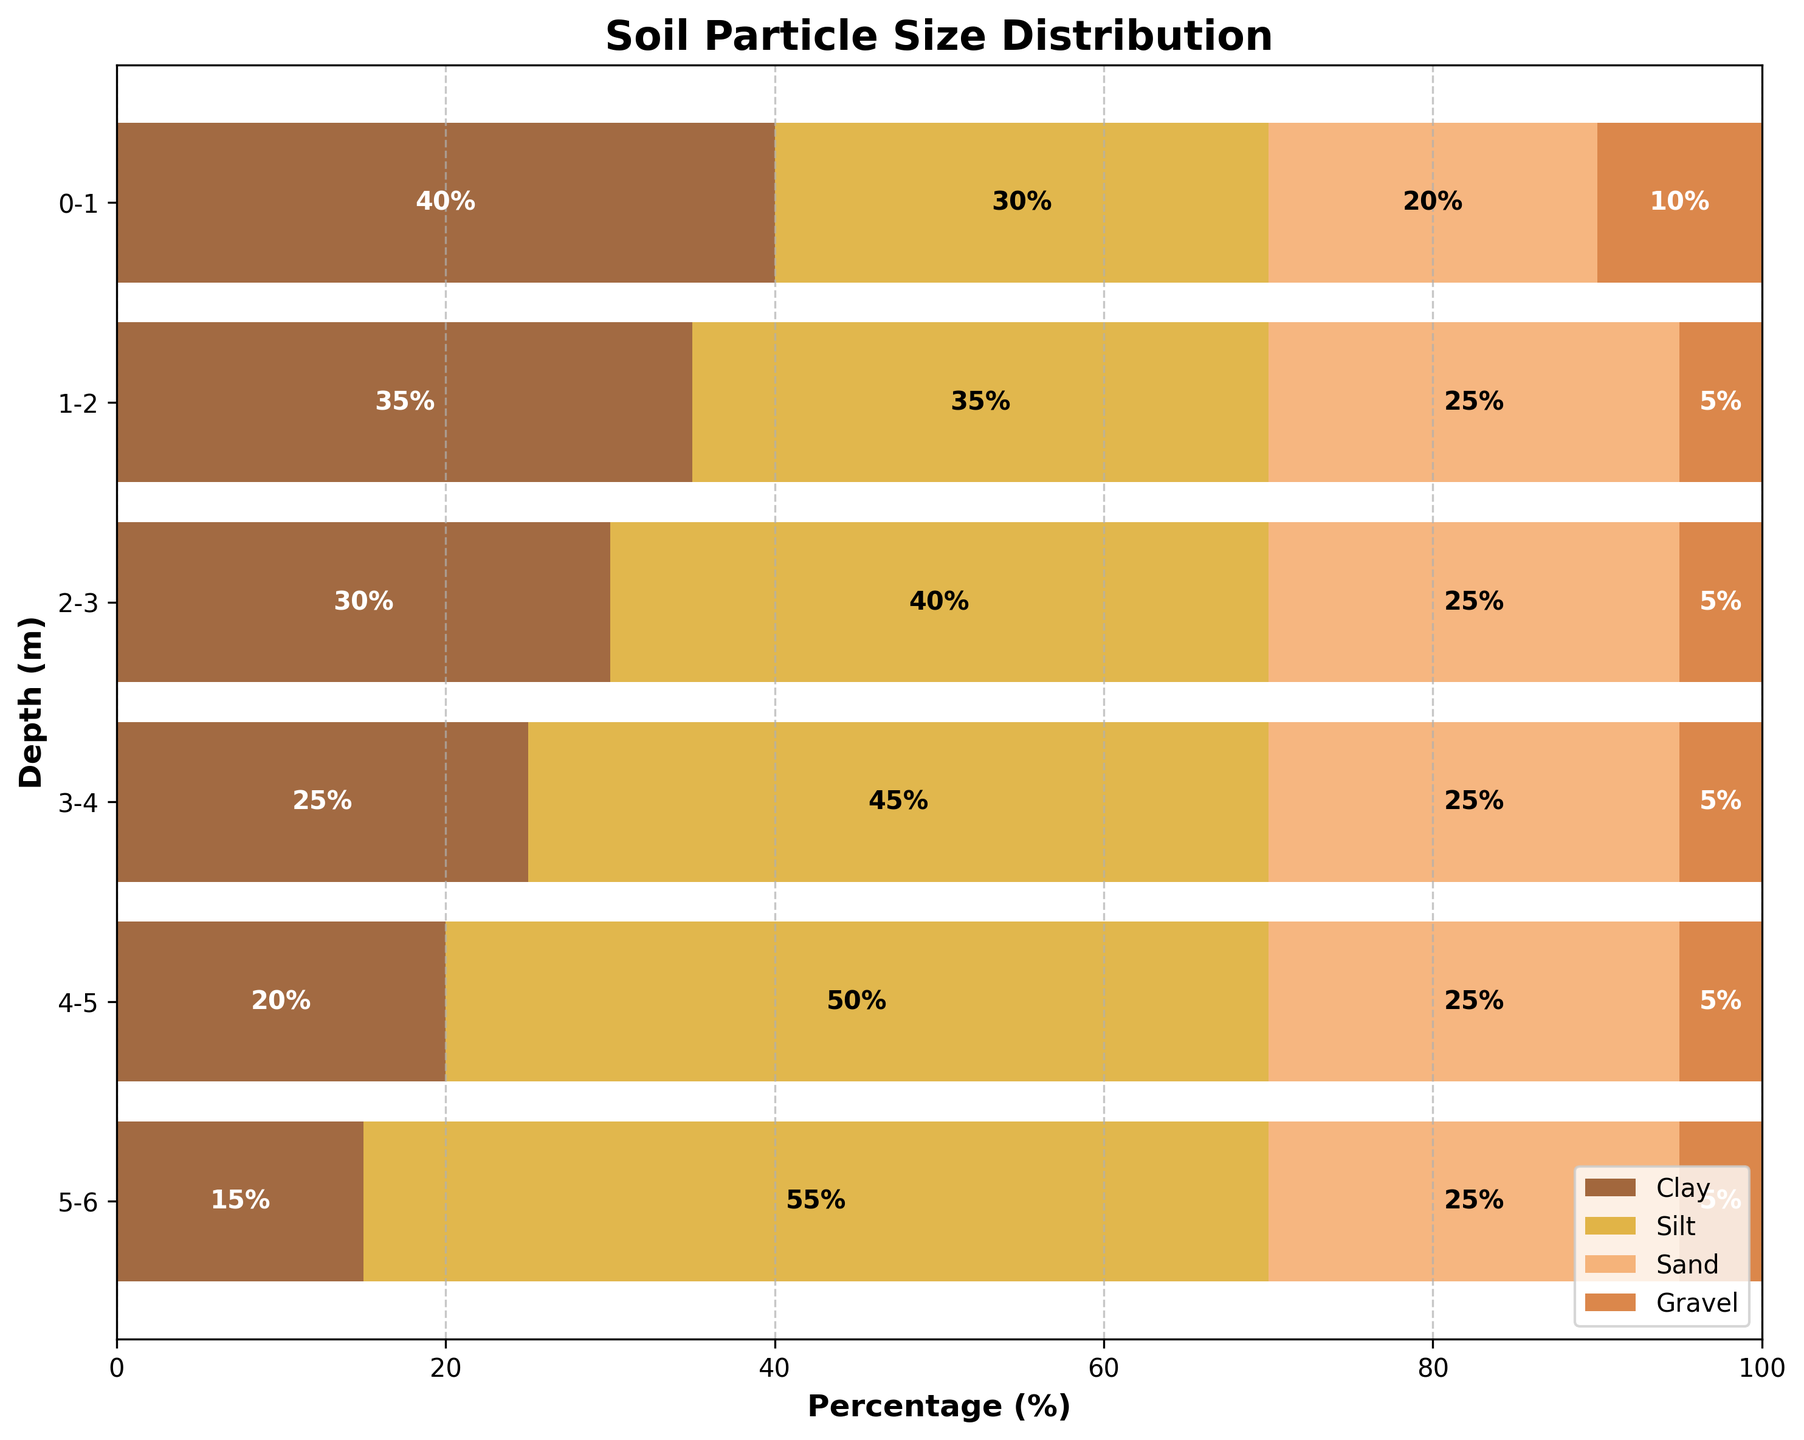What is the title of the chart? The title is typically displayed at the top of the chart and provides an overall description of what the chart is about.
Answer: Soil Particle Size Distribution How many depth intervals are shown in the chart? Count the number of different depth intervals on the y-axis.
Answer: 6 At which depth do clay particles have the highest percentage? Look for the bar segments colored for clay and find the depth where it reaches its maximum length.
Answer: 0-1 m What is the component with the smallest percentage across all depths? Compare the lowest percentage across all depths and components. Gravel maintains a very low and constant percentage.
Answer: Gravel Which depth intervals have an equal percentage of sand? Check the length of the sand segments (colored for sand) for equal lengths across different depth intervals.
Answer: All intervals What is the percentage of silt at 3-4 meters? Locate the corresponding segment for silt at the 3-4 meters depth and read the value.
Answer: 45% What is the total percentage of particles other than clay at the 1-2 meter depth interval? Add the percentages of silt, sand, and gravel at the 1-2 meter depth. 35% (silt) + 25% (sand) + 5% (gravel) = 65%.
Answer: 65% How does the percentage of clay change from 0-1 meters to 5-6 meters? Compare the percentage bars for clay at 0-1 meters and 5-6 meters.
Answer: Decreases from 40% to 15% Which depth interval has the highest proportion of silt compared to clay? Compare the ratios of silt to clay across all depth intervals and identify the highest ratio. At 5-6 meters: 55% (silt) vs 15% (clay).
Answer: 5-6 m What is the combined percentage of sand and gravel at 2-3 meters? Add the sand and gravel percentages at the 2-3 meter depth. 25% (sand) + 5% (gravel) = 30%.
Answer: 30% 